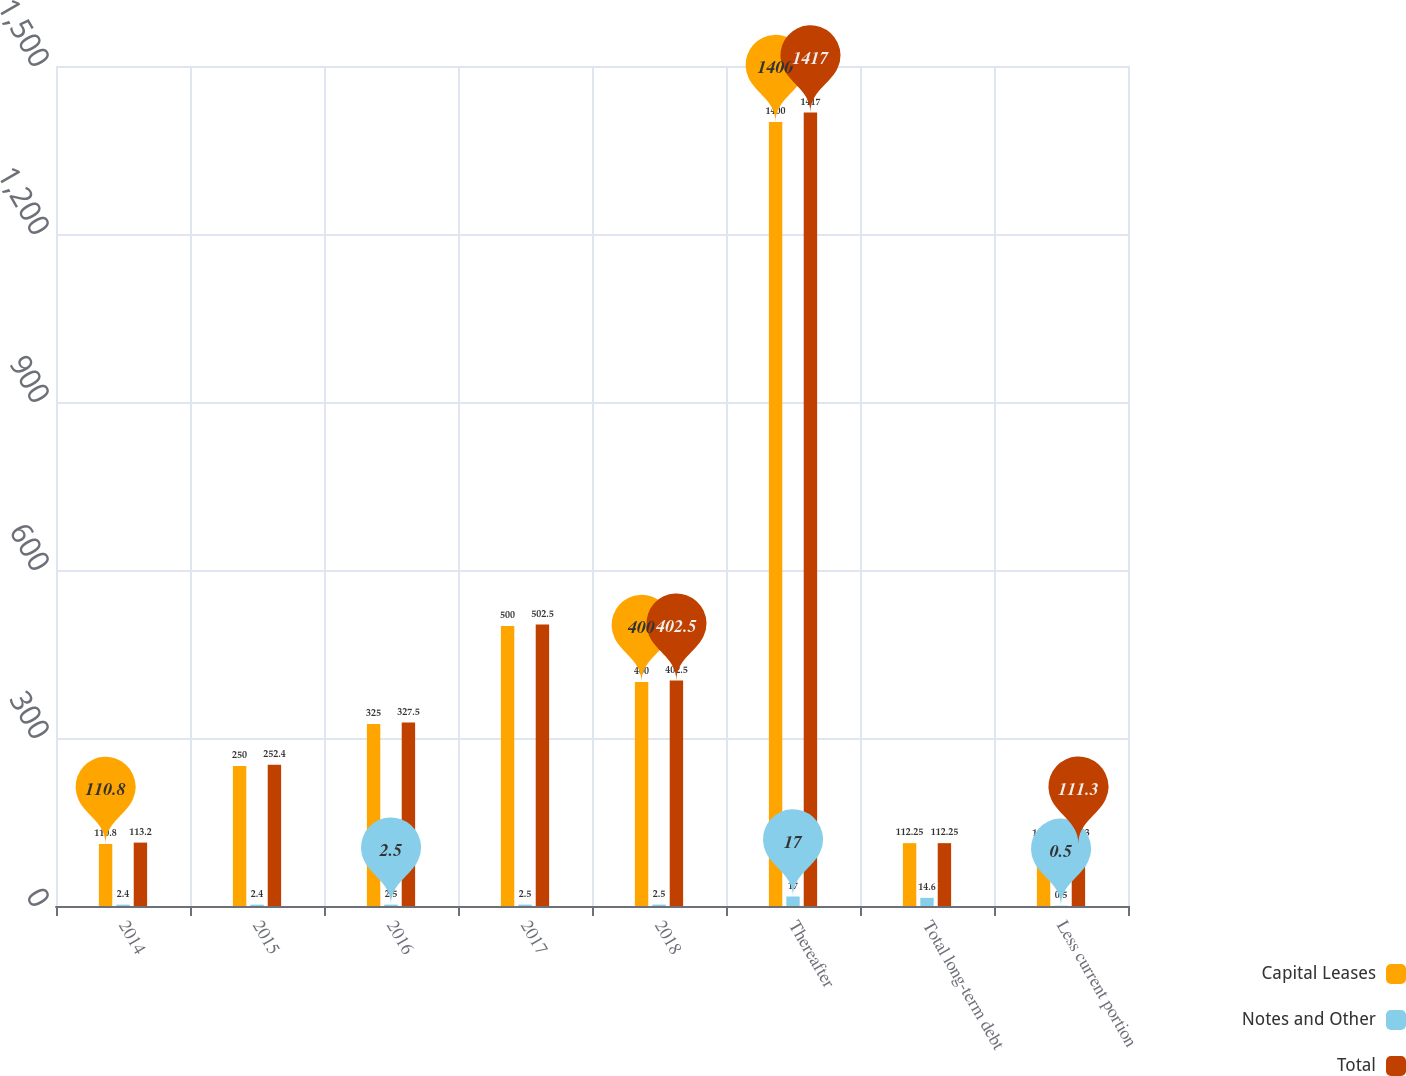Convert chart. <chart><loc_0><loc_0><loc_500><loc_500><stacked_bar_chart><ecel><fcel>2014<fcel>2015<fcel>2016<fcel>2017<fcel>2018<fcel>Thereafter<fcel>Total long-term debt<fcel>Less current portion<nl><fcel>Capital Leases<fcel>110.8<fcel>250<fcel>325<fcel>500<fcel>400<fcel>1400<fcel>112.25<fcel>110.8<nl><fcel>Notes and Other<fcel>2.4<fcel>2.4<fcel>2.5<fcel>2.5<fcel>2.5<fcel>17<fcel>14.6<fcel>0.5<nl><fcel>Total<fcel>113.2<fcel>252.4<fcel>327.5<fcel>502.5<fcel>402.5<fcel>1417<fcel>112.25<fcel>111.3<nl></chart> 